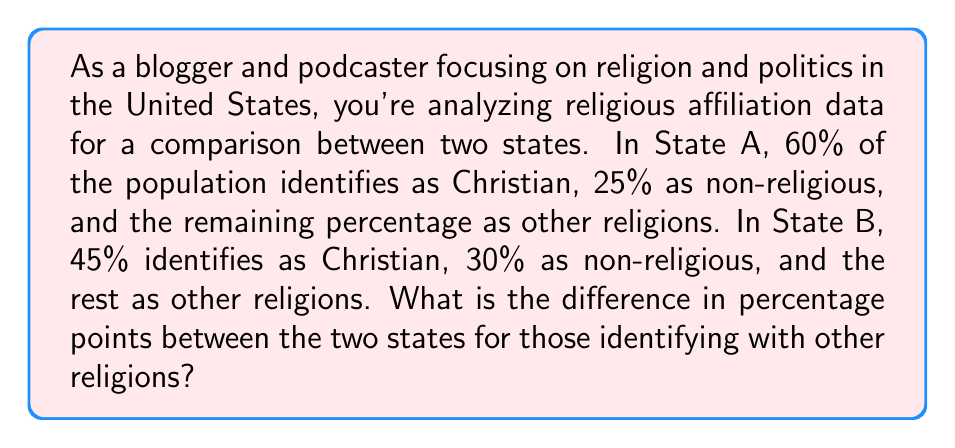Show me your answer to this math problem. To solve this problem, we need to:

1. Find the percentage of people identifying with other religions in State A:
   Let $x$ be the percentage of other religions in State A.
   $$100\% = 60\% + 25\% + x\%$$
   $$x\% = 100\% - 60\% - 25\% = 15\%$$

2. Find the percentage of people identifying with other religions in State B:
   Let $y$ be the percentage of other religions in State B.
   $$100\% = 45\% + 30\% + y\%$$
   $$y\% = 100\% - 45\% - 30\% = 25\%$$

3. Calculate the difference in percentage points:
   $$\text{Difference} = y\% - x\% = 25\% - 15\% = 10\text{ percentage points}$$
Answer: The difference in percentage points between the two states for those identifying with other religions is 10 percentage points. 